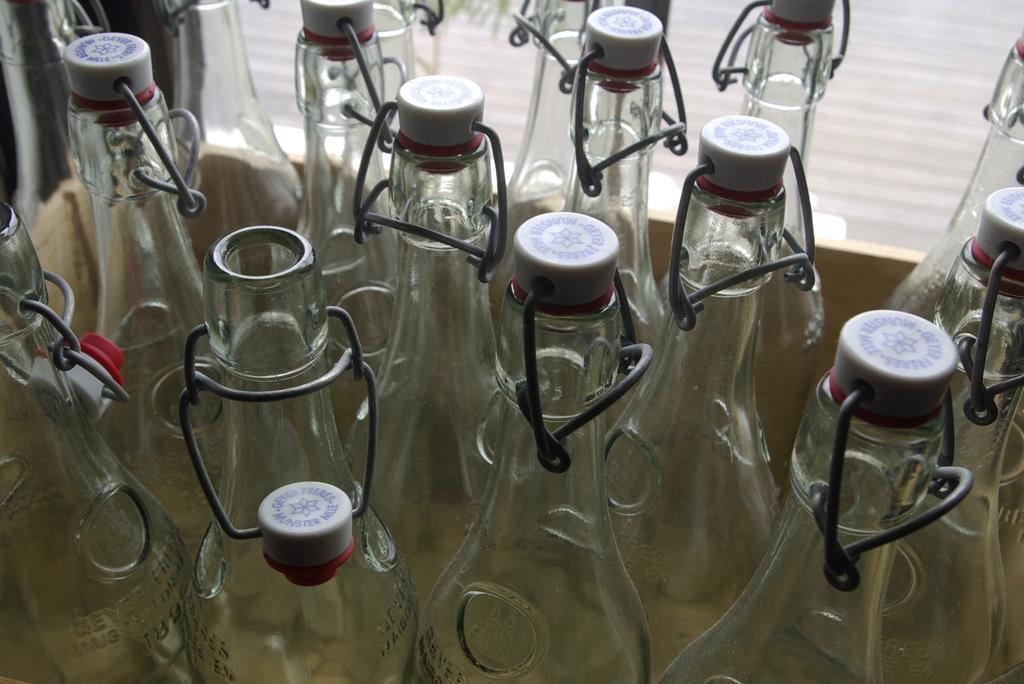What type of objects can be seen in the image? There are several glass bottles in the image. Can you describe the state of one of the bottles? One of the bottles is opened. What type of horn can be seen in the image? There is no horn present in the image; it only features glass bottles. Is there any blood visible in the image? No, there is no blood visible in the image. 